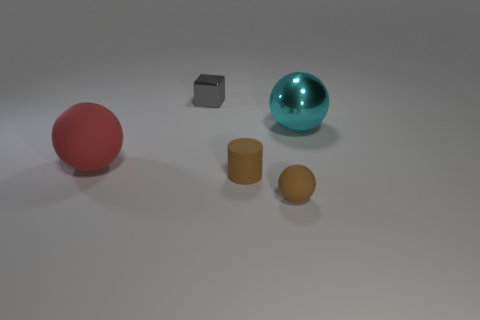Subtract all cyan balls. Subtract all cyan blocks. How many balls are left? 2 Add 3 brown objects. How many objects exist? 8 Subtract all cylinders. How many objects are left? 4 Subtract all yellow blocks. Subtract all shiny things. How many objects are left? 3 Add 2 brown objects. How many brown objects are left? 4 Add 1 cyan things. How many cyan things exist? 2 Subtract 0 purple cubes. How many objects are left? 5 